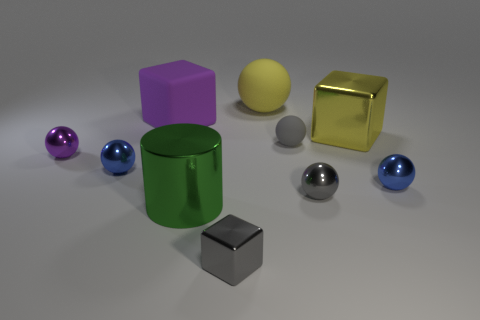Can you tell me what shapes are present in this image? Yes, the image features a variety of geometric shapes. There are three spheres, two cubes, and one cylinder. The spheres come in different colors – purple, blue, and gray. The cubes are also of different colors and finishes, with one being yellow and shiny, and the other small and gray with a matte finish. The cylinder is green and stands upright with a matte finish as well. 